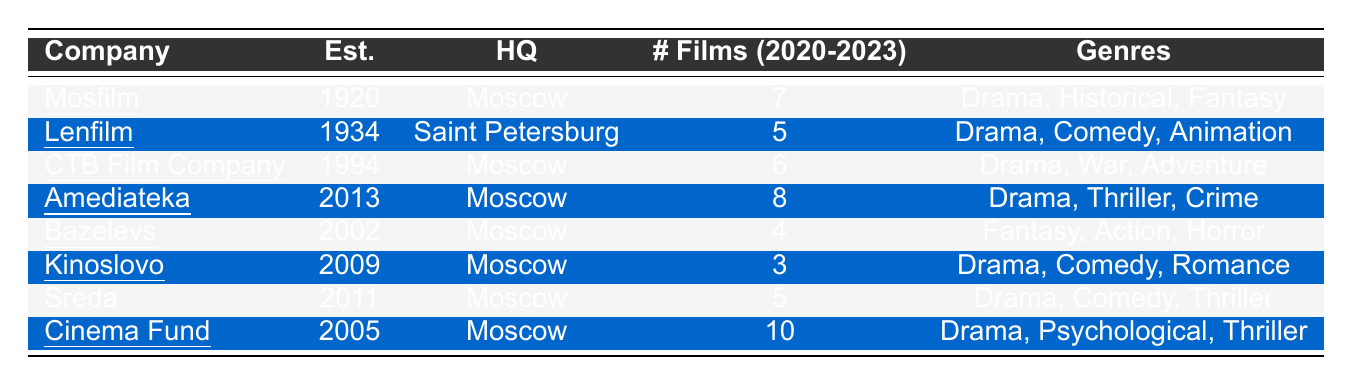What is the total number of films produced by all companies from 2020 to 2023? To find the total number of films, we can sum the number of films produced by each company: 7 (Mosfilm) + 5 (Lenfilm) + 6 (CTB Film Company) + 8 (Amediateka) + 4 (Bazelevs) + 3 (Kinoslovo) + 5 (Sreda) + 10 (Cinema Fund) = 48.
Answer: 48 Which company has produced the most films between 2020 and 2023? By looking at the number of films produced by each company, we see that Cinema Fund produced the most films with a total of 10 films.
Answer: Cinema Fund How many companies specialize in drama as a genre? We see that Mosfilm, CTB Film Company, Amediateka, Sreda, and Cinema Fund each specialize in drama. Counting them gives us a total of 5 companies.
Answer: 5 Is Lenfilm headquartered in Moscow? Lenfilm's headquarters is listed as Saint Petersburg, not Moscow. Therefore, the answer is no.
Answer: No What is the average number of films produced by the companies specialized in drama? The companies specializing in drama and their film counts are: Mosfilm (7), CTB Film Company (6), Amediateka (8), Sreda (5), and Cinema Fund (10). The sum is 7 + 6 + 8 + 5 + 10 = 36, and there are 5 companies, so the average is 36/5 = 7.2.
Answer: 7.2 Which genre is most commonly specialized in by the production companies listed? By analyzing the genres, we see that “Drama” appears in all companies except Bazelevs and Kinoslovo. Therefore, it is the most commonly specialized genre.
Answer: Drama How many films did Amediateka produce compared to Bazelevs? Amediateka produced 8 films while Bazelevs produced 4 films. The difference in their production is 8 - 4 = 4 films.
Answer: 4 Which company was established most recently? According to the established dates, Amediateka was established in 2013, which is the most recent establishment date compared to the others.
Answer: Amediateka What genres do both Sreda and Kinoslovo have in common? The genres listed are "Drama" for both production companies. Therefore, “Drama” is the only genre they have in common.
Answer: Drama Is CTB Film Company more recent than Bazelevs? CTB Film Company was established in 1994, while Bazelevs was established in 2002. Since 1994 is earlier than 2002, the statement is false.
Answer: No 